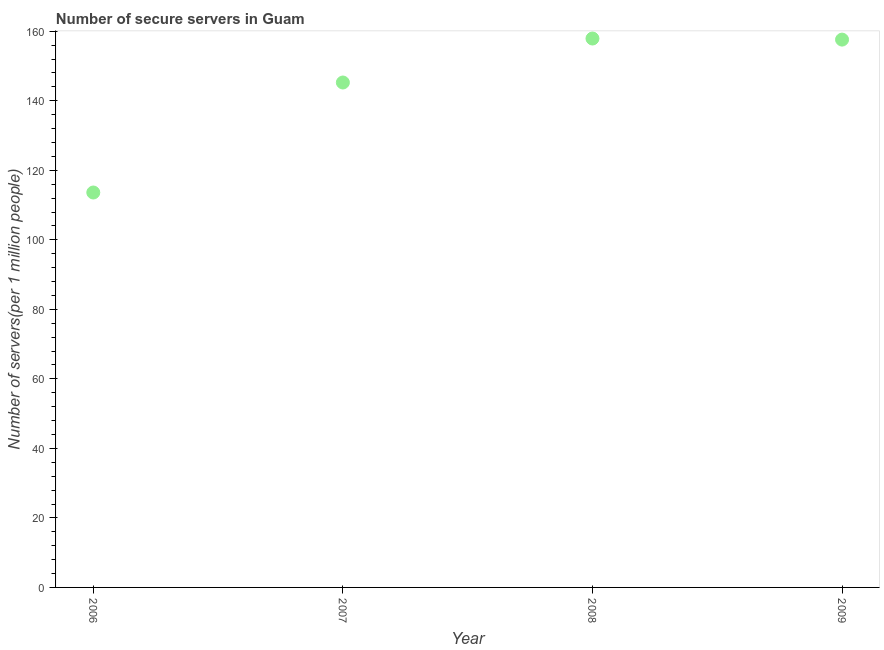What is the number of secure internet servers in 2006?
Your answer should be very brief. 113.62. Across all years, what is the maximum number of secure internet servers?
Keep it short and to the point. 157.92. Across all years, what is the minimum number of secure internet servers?
Offer a very short reply. 113.62. In which year was the number of secure internet servers minimum?
Your answer should be compact. 2006. What is the sum of the number of secure internet servers?
Ensure brevity in your answer.  574.41. What is the difference between the number of secure internet servers in 2006 and 2009?
Your response must be concise. -43.99. What is the average number of secure internet servers per year?
Provide a succinct answer. 143.6. What is the median number of secure internet servers?
Provide a succinct answer. 151.44. What is the ratio of the number of secure internet servers in 2006 to that in 2008?
Give a very brief answer. 0.72. Is the difference between the number of secure internet servers in 2006 and 2007 greater than the difference between any two years?
Your response must be concise. No. What is the difference between the highest and the second highest number of secure internet servers?
Keep it short and to the point. 0.31. Is the sum of the number of secure internet servers in 2006 and 2009 greater than the maximum number of secure internet servers across all years?
Keep it short and to the point. Yes. What is the difference between the highest and the lowest number of secure internet servers?
Make the answer very short. 44.3. What is the difference between two consecutive major ticks on the Y-axis?
Your response must be concise. 20. Are the values on the major ticks of Y-axis written in scientific E-notation?
Make the answer very short. No. What is the title of the graph?
Give a very brief answer. Number of secure servers in Guam. What is the label or title of the X-axis?
Give a very brief answer. Year. What is the label or title of the Y-axis?
Make the answer very short. Number of servers(per 1 million people). What is the Number of servers(per 1 million people) in 2006?
Provide a short and direct response. 113.62. What is the Number of servers(per 1 million people) in 2007?
Ensure brevity in your answer.  145.26. What is the Number of servers(per 1 million people) in 2008?
Keep it short and to the point. 157.92. What is the Number of servers(per 1 million people) in 2009?
Your answer should be compact. 157.61. What is the difference between the Number of servers(per 1 million people) in 2006 and 2007?
Your answer should be very brief. -31.65. What is the difference between the Number of servers(per 1 million people) in 2006 and 2008?
Offer a very short reply. -44.3. What is the difference between the Number of servers(per 1 million people) in 2006 and 2009?
Ensure brevity in your answer.  -43.99. What is the difference between the Number of servers(per 1 million people) in 2007 and 2008?
Your answer should be compact. -12.65. What is the difference between the Number of servers(per 1 million people) in 2007 and 2009?
Make the answer very short. -12.34. What is the difference between the Number of servers(per 1 million people) in 2008 and 2009?
Your answer should be compact. 0.31. What is the ratio of the Number of servers(per 1 million people) in 2006 to that in 2007?
Provide a short and direct response. 0.78. What is the ratio of the Number of servers(per 1 million people) in 2006 to that in 2008?
Your answer should be compact. 0.72. What is the ratio of the Number of servers(per 1 million people) in 2006 to that in 2009?
Offer a very short reply. 0.72. What is the ratio of the Number of servers(per 1 million people) in 2007 to that in 2009?
Your response must be concise. 0.92. 